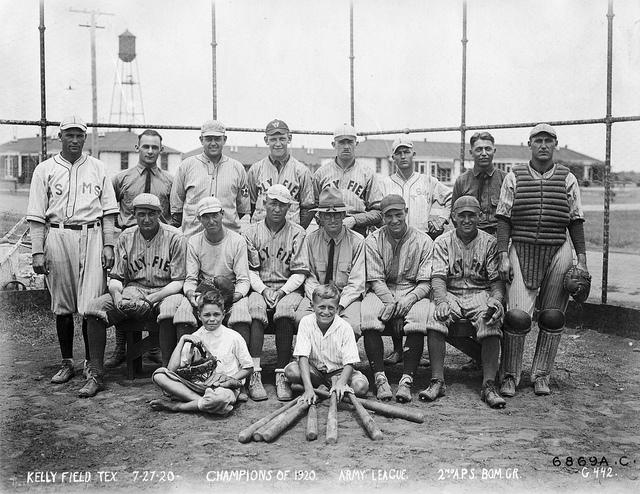What role does the most heavily armored person shown here hold? catcher 